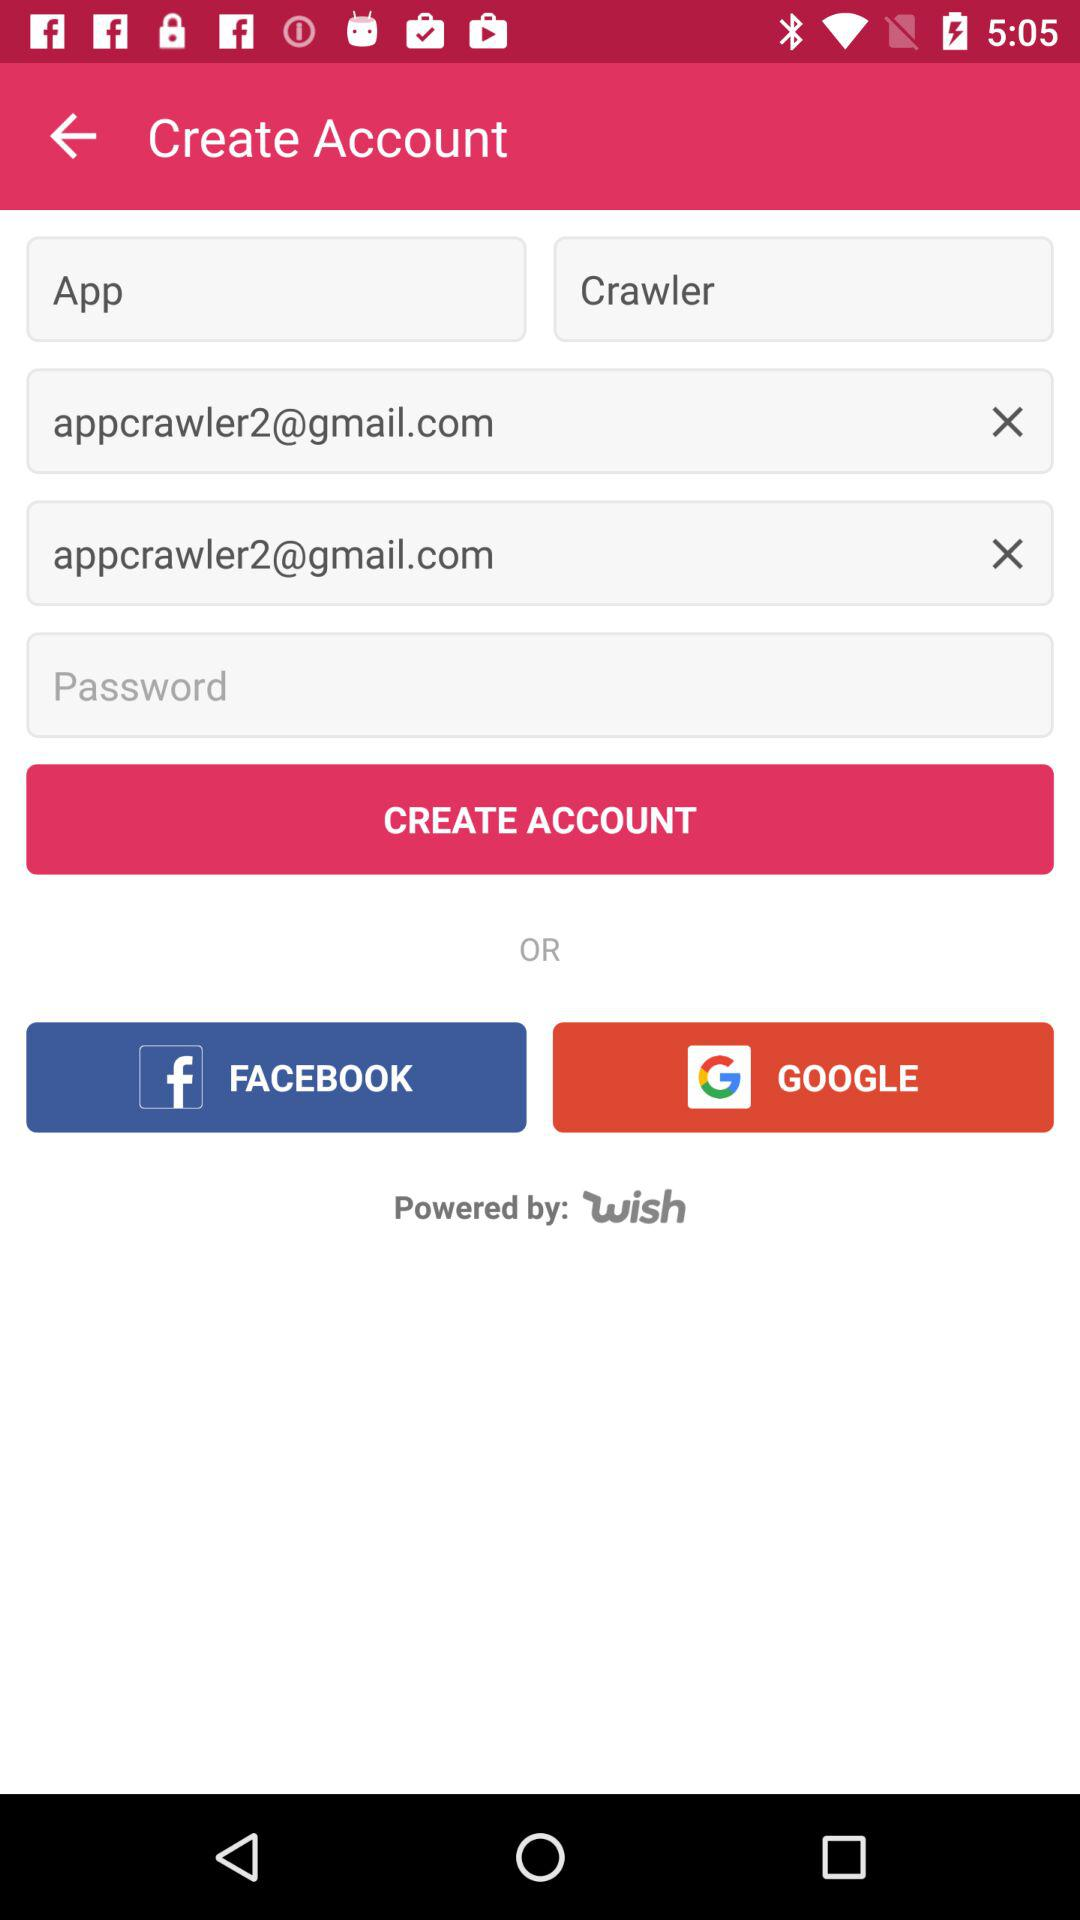What are the different options available for logging in? The different options are "FACEBOOK" and "GOOGLE". 